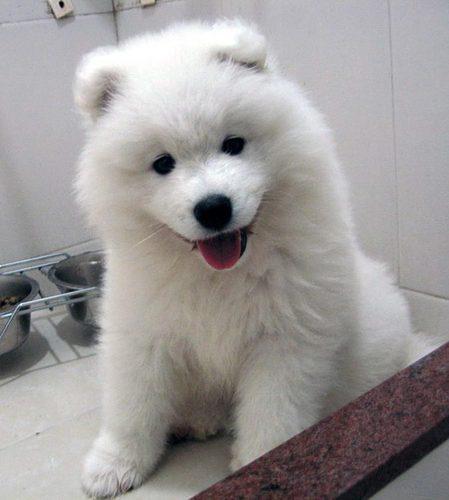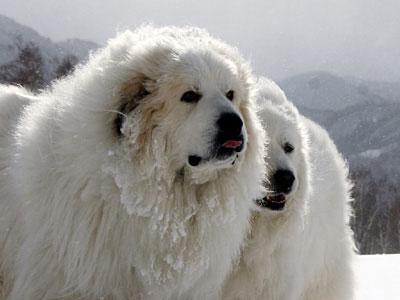The first image is the image on the left, the second image is the image on the right. For the images shown, is this caption "At least one of the dogs has its tongue sticking out." true? Answer yes or no. Yes. The first image is the image on the left, the second image is the image on the right. For the images shown, is this caption "Dogs are sticking out their tongues far enough for the tongues to be visible." true? Answer yes or no. Yes. 